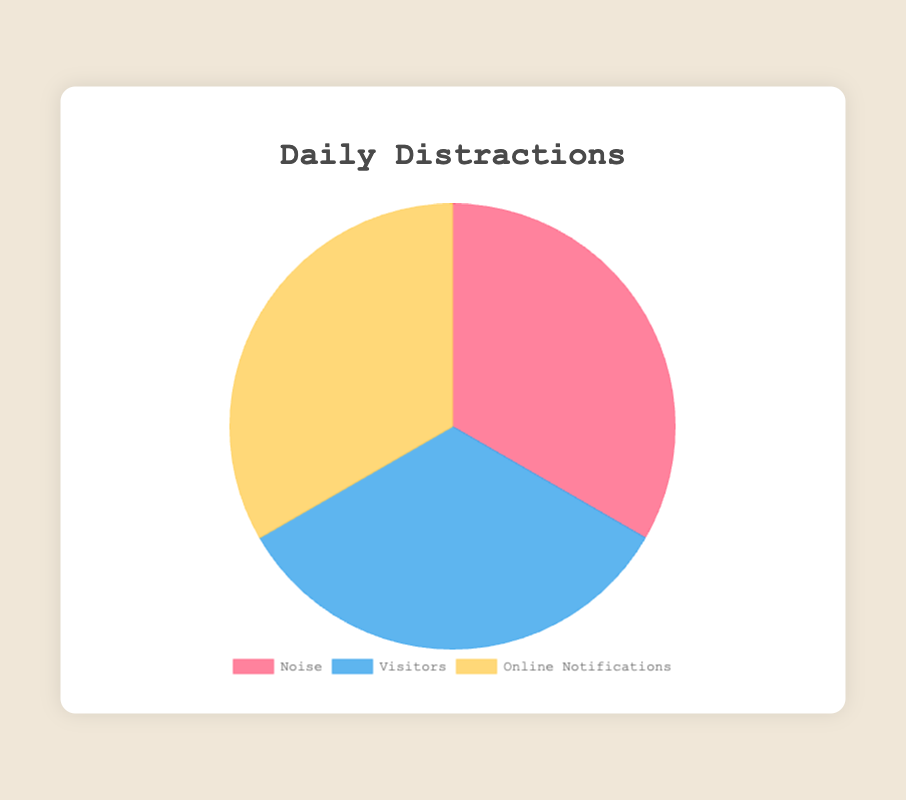Which category has the highest percentage of distractions? The category "Online Notifications" has the highest percentage of the distractions since it has the largest pie slice.
Answer: Online Notifications Which category causes fewer distractions, Noise or Visitors? By comparing the chart slices, the slice for "Visitors" is larger than the slice for "Noise," indicating that Visitors cause more distractions than Noise.
Answer: Noise What is the combined percentage for "Social Media Alerts" and "Work Emails" within Online Notifications? Social Media Alerts have 50%, and Work Emails have 30%. Summing these up, the combined percentage is 50% + 30% = 80%.
Answer: 80% Which subcategory contributes the least among the categories of Noise and Online Notifications? Street Performers under Noise have the smallest percentage at 10%, and it is equal to News Alerts and App Updates under Online Notifications. So, any of these three subcategories could be the answer.
Answer: Street Performers, News Alerts, App Updates What is the total percentage of distractions caused by "Traffic Noise" and "Friends"? Traffic Noise causes 30%, and Friends cause 40%. Adding these together, the total is 30% + 40% = 70%.
Answer: 70% If "Delivery People" doubled their rate of causing distractions, would they surpass any other subcategory in Visitors? Delivery People currently have 15%. If doubled, it would be 15% * 2 = 30%. They would still not surpass the leading Visitors subcategories, Friends (40%) and Family (35%).
Answer: No Which category contributes the most to the total distractions, and how much higher is it compared to the least contributing category? Online Notifications have the greatest contribution, and Noise has the least. Given the slices for Online Notifications (50% from Social Media Alerts, 30% from Work Emails, etc.) and Noise (30% from Traffic Noise, 25% from Construction Noise, etc.), Online Notifications are higher by a significant portion.
Answer: Online Notifications, significantly higher How much higher is the percentage of "Friends" compared to "Delivery People" under the Visitors category? Friends have 40%, while Delivery People have 15%. The difference is 40% - 15% = 25%.
Answer: 25% What proportion of distractions does the combined "Noise" category have relative to the combined "Visitors" category? Adding the subcategories under Noise (30% + 25% + 20% + 15% + 10%) equals 100%, and similarly for Visitors (40% + 35% + 15% + 10%) equates to 100%. Both contribute equally in proportion.
Answer: Equal proportions 